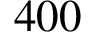Convert formula to latex. <formula><loc_0><loc_0><loc_500><loc_500>4 0 0</formula> 